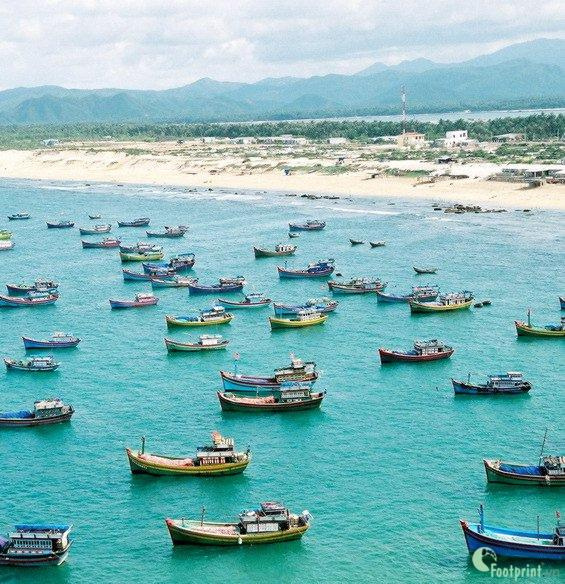Identify the text displayed in this image. Foot Print 